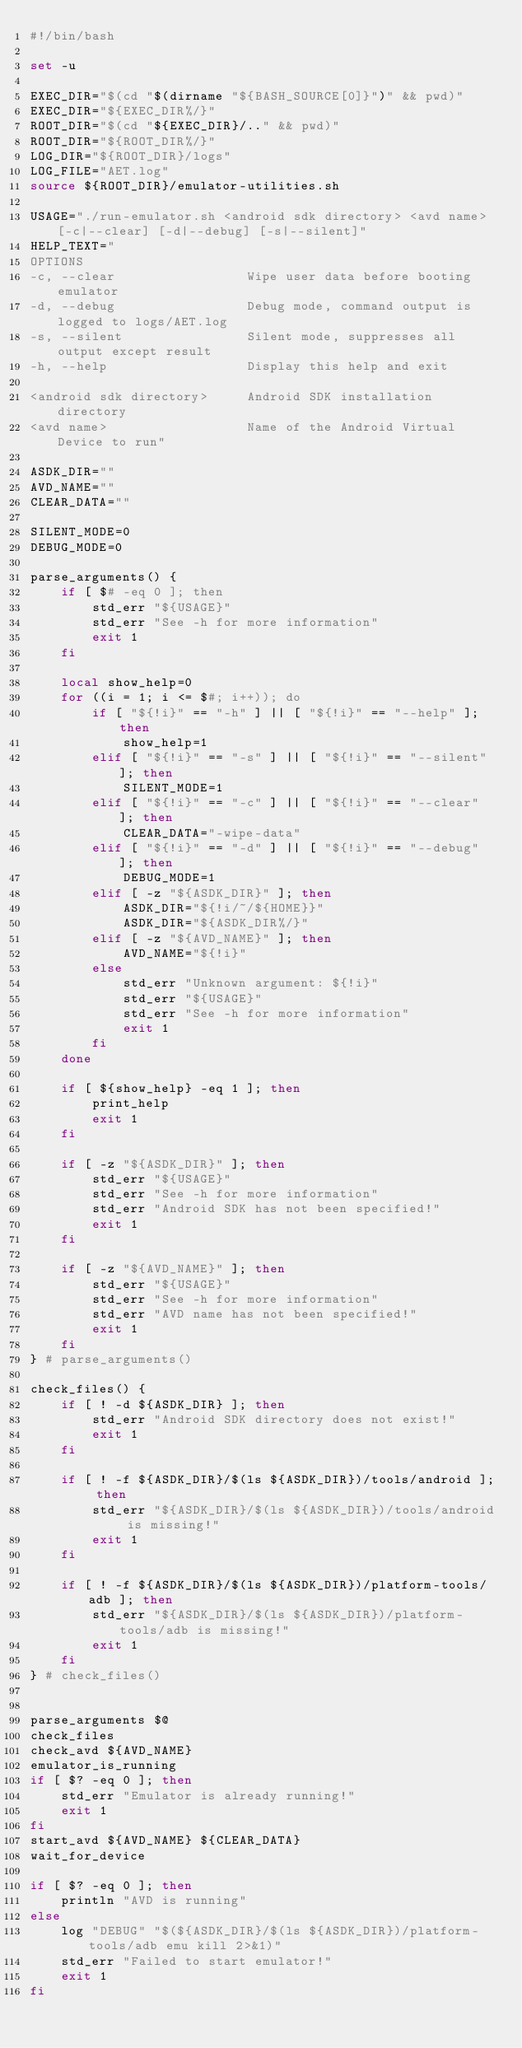Convert code to text. <code><loc_0><loc_0><loc_500><loc_500><_Bash_>#!/bin/bash

set -u

EXEC_DIR="$(cd "$(dirname "${BASH_SOURCE[0]}")" && pwd)"
EXEC_DIR="${EXEC_DIR%/}"
ROOT_DIR="$(cd "${EXEC_DIR}/.." && pwd)"
ROOT_DIR="${ROOT_DIR%/}"
LOG_DIR="${ROOT_DIR}/logs"
LOG_FILE="AET.log"
source ${ROOT_DIR}/emulator-utilities.sh

USAGE="./run-emulator.sh <android sdk directory> <avd name> [-c|--clear] [-d|--debug] [-s|--silent]"
HELP_TEXT="
OPTIONS
-c, --clear                 Wipe user data before booting emulator
-d, --debug                 Debug mode, command output is logged to logs/AET.log
-s, --silent                Silent mode, suppresses all output except result
-h, --help                  Display this help and exit

<android sdk directory>     Android SDK installation directory
<avd name>                  Name of the Android Virtual Device to run"

ASDK_DIR=""
AVD_NAME=""
CLEAR_DATA=""

SILENT_MODE=0
DEBUG_MODE=0

parse_arguments() {
    if [ $# -eq 0 ]; then
        std_err "${USAGE}"
        std_err "See -h for more information"
        exit 1
    fi

    local show_help=0
    for ((i = 1; i <= $#; i++)); do
        if [ "${!i}" == "-h" ] || [ "${!i}" == "--help" ]; then
            show_help=1
        elif [ "${!i}" == "-s" ] || [ "${!i}" == "--silent" ]; then
            SILENT_MODE=1
        elif [ "${!i}" == "-c" ] || [ "${!i}" == "--clear" ]; then
            CLEAR_DATA="-wipe-data"
        elif [ "${!i}" == "-d" ] || [ "${!i}" == "--debug" ]; then
            DEBUG_MODE=1
        elif [ -z "${ASDK_DIR}" ]; then
            ASDK_DIR="${!i/~/${HOME}}"
            ASDK_DIR="${ASDK_DIR%/}"
        elif [ -z "${AVD_NAME}" ]; then
            AVD_NAME="${!i}"
        else
            std_err "Unknown argument: ${!i}"
            std_err "${USAGE}"
            std_err "See -h for more information"
            exit 1
        fi
    done

    if [ ${show_help} -eq 1 ]; then
        print_help
        exit 1
    fi

    if [ -z "${ASDK_DIR}" ]; then
        std_err "${USAGE}"
        std_err "See -h for more information"
        std_err "Android SDK has not been specified!"
        exit 1
    fi

    if [ -z "${AVD_NAME}" ]; then
        std_err "${USAGE}"
        std_err "See -h for more information"
        std_err "AVD name has not been specified!"
        exit 1
    fi
} # parse_arguments()

check_files() {
    if [ ! -d ${ASDK_DIR} ]; then
        std_err "Android SDK directory does not exist!"
        exit 1
    fi

    if [ ! -f ${ASDK_DIR}/$(ls ${ASDK_DIR})/tools/android ]; then
        std_err "${ASDK_DIR}/$(ls ${ASDK_DIR})/tools/android is missing!"
        exit 1
    fi

    if [ ! -f ${ASDK_DIR}/$(ls ${ASDK_DIR})/platform-tools/adb ]; then
        std_err "${ASDK_DIR}/$(ls ${ASDK_DIR})/platform-tools/adb is missing!"
        exit 1
    fi
} # check_files()


parse_arguments $@
check_files
check_avd ${AVD_NAME}
emulator_is_running
if [ $? -eq 0 ]; then
    std_err "Emulator is already running!"
    exit 1
fi
start_avd ${AVD_NAME} ${CLEAR_DATA}
wait_for_device

if [ $? -eq 0 ]; then
    println "AVD is running"
else
    log "DEBUG" "$(${ASDK_DIR}/$(ls ${ASDK_DIR})/platform-tools/adb emu kill 2>&1)"
    std_err "Failed to start emulator!"
    exit 1
fi
</code> 